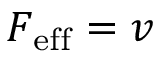<formula> <loc_0><loc_0><loc_500><loc_500>F _ { e f f } = v</formula> 